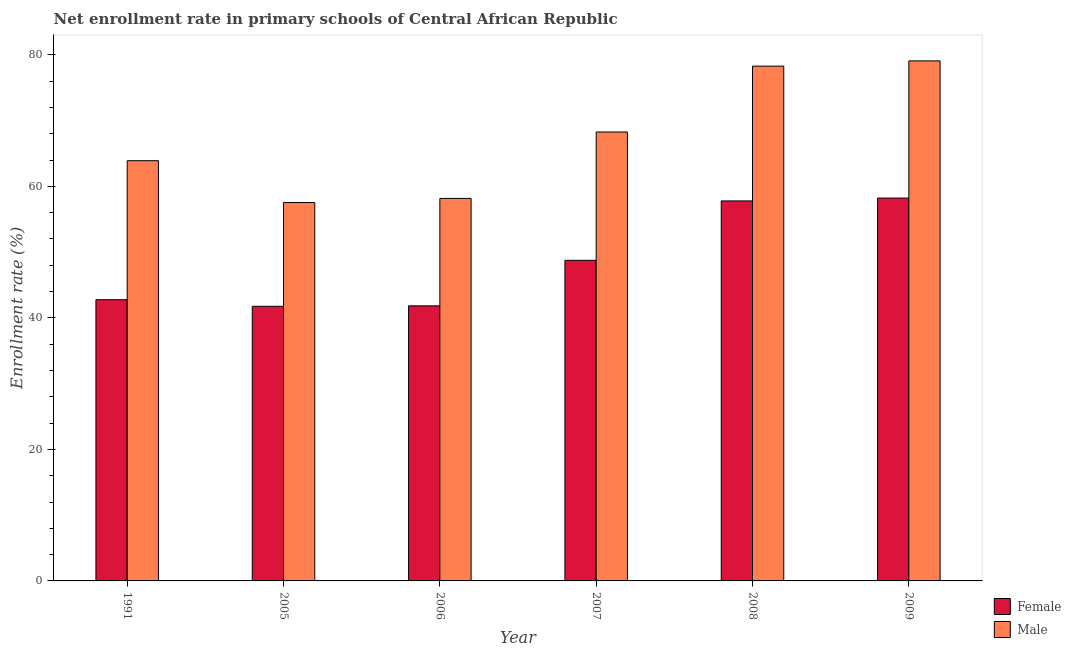How many different coloured bars are there?
Your answer should be very brief. 2. Are the number of bars on each tick of the X-axis equal?
Give a very brief answer. Yes. How many bars are there on the 6th tick from the right?
Keep it short and to the point. 2. What is the enrollment rate of female students in 2007?
Keep it short and to the point. 48.75. Across all years, what is the maximum enrollment rate of male students?
Your answer should be compact. 79.08. Across all years, what is the minimum enrollment rate of female students?
Ensure brevity in your answer.  41.76. In which year was the enrollment rate of female students minimum?
Offer a very short reply. 2005. What is the total enrollment rate of female students in the graph?
Keep it short and to the point. 291.1. What is the difference between the enrollment rate of male students in 1991 and that in 2007?
Your answer should be compact. -4.37. What is the difference between the enrollment rate of female students in 2006 and the enrollment rate of male students in 2007?
Your answer should be very brief. -6.92. What is the average enrollment rate of male students per year?
Provide a succinct answer. 67.54. In how many years, is the enrollment rate of female students greater than 52 %?
Keep it short and to the point. 2. What is the ratio of the enrollment rate of male students in 2005 to that in 2009?
Offer a very short reply. 0.73. Is the enrollment rate of female students in 2005 less than that in 2007?
Make the answer very short. Yes. What is the difference between the highest and the second highest enrollment rate of male students?
Ensure brevity in your answer.  0.8. What is the difference between the highest and the lowest enrollment rate of male students?
Provide a succinct answer. 21.54. What does the 1st bar from the right in 2006 represents?
Provide a succinct answer. Male. How many years are there in the graph?
Your answer should be compact. 6. What is the difference between two consecutive major ticks on the Y-axis?
Give a very brief answer. 20. Are the values on the major ticks of Y-axis written in scientific E-notation?
Keep it short and to the point. No. How are the legend labels stacked?
Ensure brevity in your answer.  Vertical. What is the title of the graph?
Your response must be concise. Net enrollment rate in primary schools of Central African Republic. Does "Passenger Transport Items" appear as one of the legend labels in the graph?
Your answer should be very brief. No. What is the label or title of the Y-axis?
Your answer should be very brief. Enrollment rate (%). What is the Enrollment rate (%) of Female in 1991?
Provide a succinct answer. 42.76. What is the Enrollment rate (%) in Male in 1991?
Offer a terse response. 63.9. What is the Enrollment rate (%) of Female in 2005?
Your answer should be very brief. 41.76. What is the Enrollment rate (%) of Male in 2005?
Your answer should be very brief. 57.54. What is the Enrollment rate (%) of Female in 2006?
Keep it short and to the point. 41.83. What is the Enrollment rate (%) of Male in 2006?
Provide a short and direct response. 58.16. What is the Enrollment rate (%) in Female in 2007?
Offer a very short reply. 48.75. What is the Enrollment rate (%) in Male in 2007?
Provide a short and direct response. 68.26. What is the Enrollment rate (%) of Female in 2008?
Make the answer very short. 57.78. What is the Enrollment rate (%) of Male in 2008?
Keep it short and to the point. 78.28. What is the Enrollment rate (%) of Female in 2009?
Provide a succinct answer. 58.22. What is the Enrollment rate (%) in Male in 2009?
Offer a very short reply. 79.08. Across all years, what is the maximum Enrollment rate (%) of Female?
Ensure brevity in your answer.  58.22. Across all years, what is the maximum Enrollment rate (%) in Male?
Offer a very short reply. 79.08. Across all years, what is the minimum Enrollment rate (%) in Female?
Make the answer very short. 41.76. Across all years, what is the minimum Enrollment rate (%) in Male?
Offer a terse response. 57.54. What is the total Enrollment rate (%) in Female in the graph?
Ensure brevity in your answer.  291.1. What is the total Enrollment rate (%) in Male in the graph?
Offer a terse response. 405.22. What is the difference between the Enrollment rate (%) in Male in 1991 and that in 2005?
Your response must be concise. 6.36. What is the difference between the Enrollment rate (%) in Female in 1991 and that in 2006?
Offer a terse response. 0.93. What is the difference between the Enrollment rate (%) of Male in 1991 and that in 2006?
Offer a very short reply. 5.73. What is the difference between the Enrollment rate (%) of Female in 1991 and that in 2007?
Make the answer very short. -5.99. What is the difference between the Enrollment rate (%) of Male in 1991 and that in 2007?
Your answer should be compact. -4.37. What is the difference between the Enrollment rate (%) in Female in 1991 and that in 2008?
Your answer should be very brief. -15.02. What is the difference between the Enrollment rate (%) of Male in 1991 and that in 2008?
Provide a succinct answer. -14.38. What is the difference between the Enrollment rate (%) in Female in 1991 and that in 2009?
Make the answer very short. -15.45. What is the difference between the Enrollment rate (%) in Male in 1991 and that in 2009?
Ensure brevity in your answer.  -15.18. What is the difference between the Enrollment rate (%) in Female in 2005 and that in 2006?
Your response must be concise. -0.07. What is the difference between the Enrollment rate (%) of Male in 2005 and that in 2006?
Offer a very short reply. -0.63. What is the difference between the Enrollment rate (%) of Female in 2005 and that in 2007?
Offer a very short reply. -6.99. What is the difference between the Enrollment rate (%) in Male in 2005 and that in 2007?
Keep it short and to the point. -10.72. What is the difference between the Enrollment rate (%) of Female in 2005 and that in 2008?
Provide a succinct answer. -16.02. What is the difference between the Enrollment rate (%) in Male in 2005 and that in 2008?
Ensure brevity in your answer.  -20.74. What is the difference between the Enrollment rate (%) of Female in 2005 and that in 2009?
Your answer should be very brief. -16.46. What is the difference between the Enrollment rate (%) in Male in 2005 and that in 2009?
Ensure brevity in your answer.  -21.54. What is the difference between the Enrollment rate (%) in Female in 2006 and that in 2007?
Keep it short and to the point. -6.92. What is the difference between the Enrollment rate (%) in Male in 2006 and that in 2007?
Keep it short and to the point. -10.1. What is the difference between the Enrollment rate (%) in Female in 2006 and that in 2008?
Give a very brief answer. -15.95. What is the difference between the Enrollment rate (%) of Male in 2006 and that in 2008?
Give a very brief answer. -20.11. What is the difference between the Enrollment rate (%) in Female in 2006 and that in 2009?
Offer a very short reply. -16.39. What is the difference between the Enrollment rate (%) in Male in 2006 and that in 2009?
Offer a very short reply. -20.91. What is the difference between the Enrollment rate (%) in Female in 2007 and that in 2008?
Provide a succinct answer. -9.03. What is the difference between the Enrollment rate (%) in Male in 2007 and that in 2008?
Your response must be concise. -10.02. What is the difference between the Enrollment rate (%) in Female in 2007 and that in 2009?
Provide a short and direct response. -9.47. What is the difference between the Enrollment rate (%) of Male in 2007 and that in 2009?
Provide a short and direct response. -10.81. What is the difference between the Enrollment rate (%) in Female in 2008 and that in 2009?
Give a very brief answer. -0.44. What is the difference between the Enrollment rate (%) of Male in 2008 and that in 2009?
Your response must be concise. -0.8. What is the difference between the Enrollment rate (%) in Female in 1991 and the Enrollment rate (%) in Male in 2005?
Offer a terse response. -14.78. What is the difference between the Enrollment rate (%) in Female in 1991 and the Enrollment rate (%) in Male in 2006?
Your response must be concise. -15.4. What is the difference between the Enrollment rate (%) in Female in 1991 and the Enrollment rate (%) in Male in 2007?
Offer a very short reply. -25.5. What is the difference between the Enrollment rate (%) in Female in 1991 and the Enrollment rate (%) in Male in 2008?
Offer a terse response. -35.52. What is the difference between the Enrollment rate (%) in Female in 1991 and the Enrollment rate (%) in Male in 2009?
Ensure brevity in your answer.  -36.31. What is the difference between the Enrollment rate (%) in Female in 2005 and the Enrollment rate (%) in Male in 2006?
Provide a short and direct response. -16.41. What is the difference between the Enrollment rate (%) of Female in 2005 and the Enrollment rate (%) of Male in 2007?
Ensure brevity in your answer.  -26.5. What is the difference between the Enrollment rate (%) of Female in 2005 and the Enrollment rate (%) of Male in 2008?
Offer a very short reply. -36.52. What is the difference between the Enrollment rate (%) in Female in 2005 and the Enrollment rate (%) in Male in 2009?
Ensure brevity in your answer.  -37.32. What is the difference between the Enrollment rate (%) in Female in 2006 and the Enrollment rate (%) in Male in 2007?
Keep it short and to the point. -26.43. What is the difference between the Enrollment rate (%) in Female in 2006 and the Enrollment rate (%) in Male in 2008?
Give a very brief answer. -36.45. What is the difference between the Enrollment rate (%) of Female in 2006 and the Enrollment rate (%) of Male in 2009?
Make the answer very short. -37.25. What is the difference between the Enrollment rate (%) in Female in 2007 and the Enrollment rate (%) in Male in 2008?
Offer a very short reply. -29.53. What is the difference between the Enrollment rate (%) in Female in 2007 and the Enrollment rate (%) in Male in 2009?
Give a very brief answer. -30.33. What is the difference between the Enrollment rate (%) in Female in 2008 and the Enrollment rate (%) in Male in 2009?
Your response must be concise. -21.3. What is the average Enrollment rate (%) in Female per year?
Provide a short and direct response. 48.52. What is the average Enrollment rate (%) in Male per year?
Offer a terse response. 67.54. In the year 1991, what is the difference between the Enrollment rate (%) in Female and Enrollment rate (%) in Male?
Make the answer very short. -21.13. In the year 2005, what is the difference between the Enrollment rate (%) in Female and Enrollment rate (%) in Male?
Your answer should be compact. -15.78. In the year 2006, what is the difference between the Enrollment rate (%) in Female and Enrollment rate (%) in Male?
Your answer should be very brief. -16.33. In the year 2007, what is the difference between the Enrollment rate (%) in Female and Enrollment rate (%) in Male?
Keep it short and to the point. -19.51. In the year 2008, what is the difference between the Enrollment rate (%) in Female and Enrollment rate (%) in Male?
Provide a short and direct response. -20.5. In the year 2009, what is the difference between the Enrollment rate (%) of Female and Enrollment rate (%) of Male?
Provide a succinct answer. -20.86. What is the ratio of the Enrollment rate (%) of Female in 1991 to that in 2005?
Ensure brevity in your answer.  1.02. What is the ratio of the Enrollment rate (%) in Male in 1991 to that in 2005?
Give a very brief answer. 1.11. What is the ratio of the Enrollment rate (%) in Female in 1991 to that in 2006?
Your answer should be compact. 1.02. What is the ratio of the Enrollment rate (%) in Male in 1991 to that in 2006?
Your answer should be very brief. 1.1. What is the ratio of the Enrollment rate (%) in Female in 1991 to that in 2007?
Provide a short and direct response. 0.88. What is the ratio of the Enrollment rate (%) of Male in 1991 to that in 2007?
Provide a succinct answer. 0.94. What is the ratio of the Enrollment rate (%) in Female in 1991 to that in 2008?
Provide a short and direct response. 0.74. What is the ratio of the Enrollment rate (%) of Male in 1991 to that in 2008?
Give a very brief answer. 0.82. What is the ratio of the Enrollment rate (%) of Female in 1991 to that in 2009?
Give a very brief answer. 0.73. What is the ratio of the Enrollment rate (%) in Male in 1991 to that in 2009?
Your answer should be very brief. 0.81. What is the ratio of the Enrollment rate (%) in Female in 2005 to that in 2006?
Keep it short and to the point. 1. What is the ratio of the Enrollment rate (%) in Male in 2005 to that in 2006?
Provide a succinct answer. 0.99. What is the ratio of the Enrollment rate (%) of Female in 2005 to that in 2007?
Provide a succinct answer. 0.86. What is the ratio of the Enrollment rate (%) in Male in 2005 to that in 2007?
Make the answer very short. 0.84. What is the ratio of the Enrollment rate (%) of Female in 2005 to that in 2008?
Provide a succinct answer. 0.72. What is the ratio of the Enrollment rate (%) in Male in 2005 to that in 2008?
Your response must be concise. 0.74. What is the ratio of the Enrollment rate (%) in Female in 2005 to that in 2009?
Offer a very short reply. 0.72. What is the ratio of the Enrollment rate (%) in Male in 2005 to that in 2009?
Ensure brevity in your answer.  0.73. What is the ratio of the Enrollment rate (%) of Female in 2006 to that in 2007?
Provide a succinct answer. 0.86. What is the ratio of the Enrollment rate (%) of Male in 2006 to that in 2007?
Make the answer very short. 0.85. What is the ratio of the Enrollment rate (%) of Female in 2006 to that in 2008?
Ensure brevity in your answer.  0.72. What is the ratio of the Enrollment rate (%) of Male in 2006 to that in 2008?
Ensure brevity in your answer.  0.74. What is the ratio of the Enrollment rate (%) in Female in 2006 to that in 2009?
Offer a terse response. 0.72. What is the ratio of the Enrollment rate (%) of Male in 2006 to that in 2009?
Your answer should be compact. 0.74. What is the ratio of the Enrollment rate (%) of Female in 2007 to that in 2008?
Offer a terse response. 0.84. What is the ratio of the Enrollment rate (%) of Male in 2007 to that in 2008?
Your answer should be compact. 0.87. What is the ratio of the Enrollment rate (%) of Female in 2007 to that in 2009?
Ensure brevity in your answer.  0.84. What is the ratio of the Enrollment rate (%) in Male in 2007 to that in 2009?
Keep it short and to the point. 0.86. What is the difference between the highest and the second highest Enrollment rate (%) in Female?
Give a very brief answer. 0.44. What is the difference between the highest and the second highest Enrollment rate (%) in Male?
Make the answer very short. 0.8. What is the difference between the highest and the lowest Enrollment rate (%) in Female?
Provide a short and direct response. 16.46. What is the difference between the highest and the lowest Enrollment rate (%) of Male?
Make the answer very short. 21.54. 